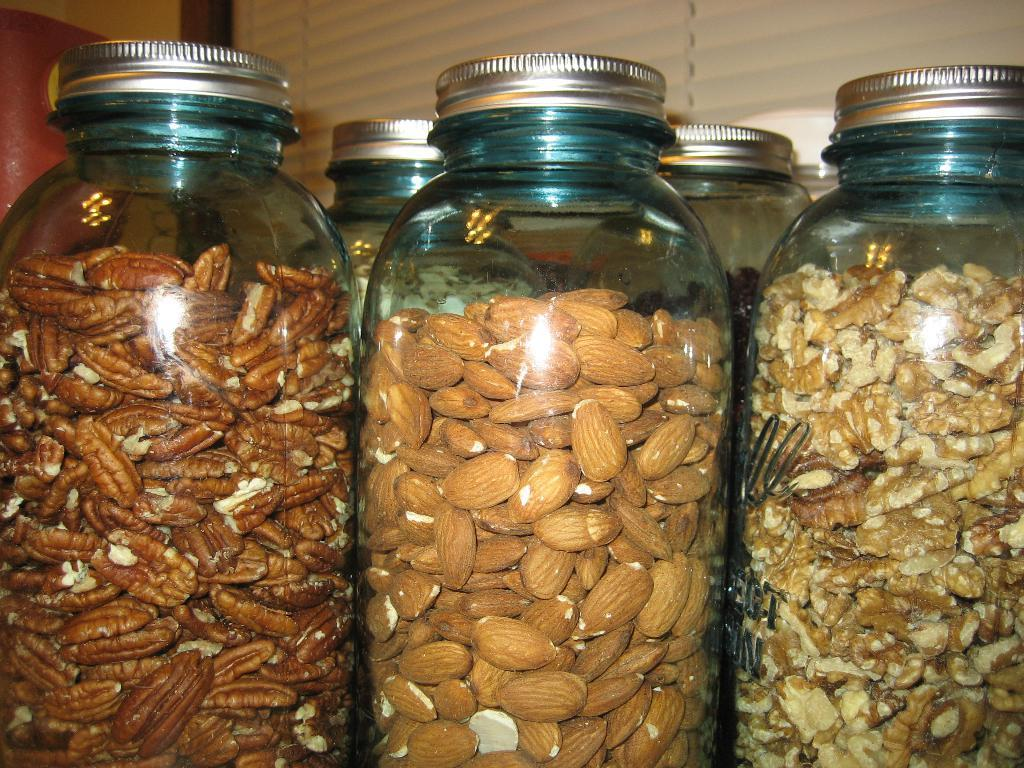What objects are present in the image? There are jars in the image. What are the jars filled with? The jars are filled with dry fruits. What type of apparel is being modeled by the dolls in the image? There are no dolls present in the image, so it is not possible to answer that question. 